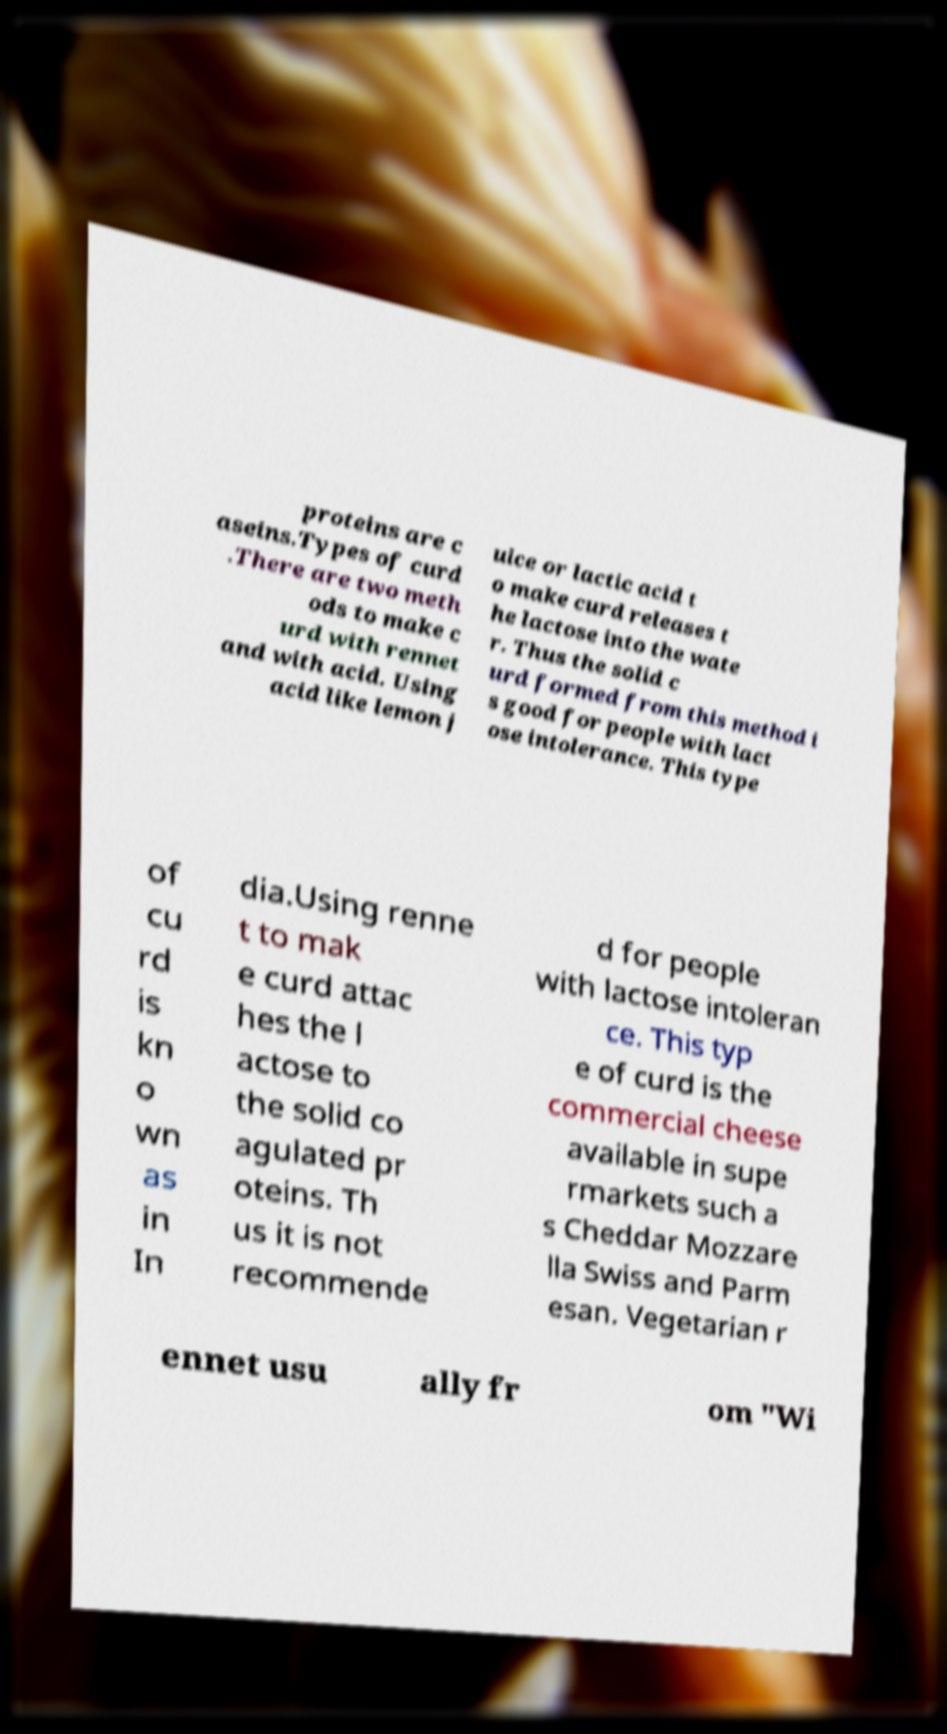Could you assist in decoding the text presented in this image and type it out clearly? proteins are c aseins.Types of curd .There are two meth ods to make c urd with rennet and with acid. Using acid like lemon j uice or lactic acid t o make curd releases t he lactose into the wate r. Thus the solid c urd formed from this method i s good for people with lact ose intolerance. This type of cu rd is kn o wn as in In dia.Using renne t to mak e curd attac hes the l actose to the solid co agulated pr oteins. Th us it is not recommende d for people with lactose intoleran ce. This typ e of curd is the commercial cheese available in supe rmarkets such a s Cheddar Mozzare lla Swiss and Parm esan. Vegetarian r ennet usu ally fr om "Wi 